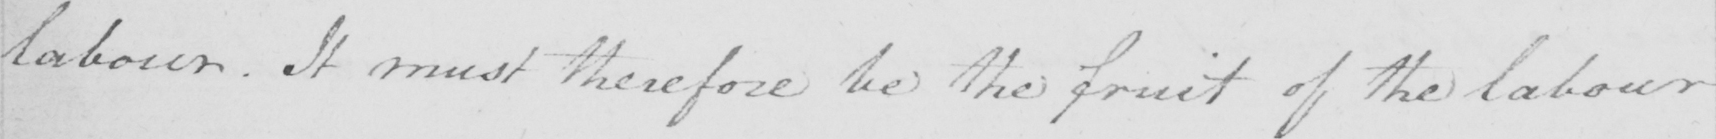What text is written in this handwritten line? labour . It must therefore be the fruit of the labour 